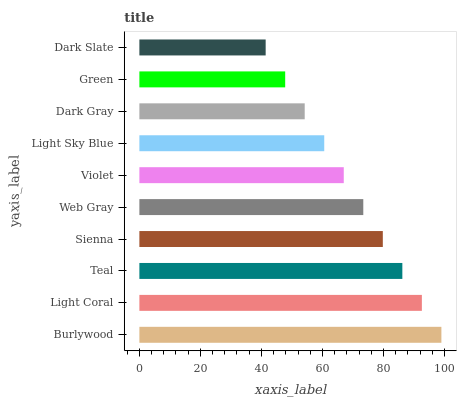Is Dark Slate the minimum?
Answer yes or no. Yes. Is Burlywood the maximum?
Answer yes or no. Yes. Is Light Coral the minimum?
Answer yes or no. No. Is Light Coral the maximum?
Answer yes or no. No. Is Burlywood greater than Light Coral?
Answer yes or no. Yes. Is Light Coral less than Burlywood?
Answer yes or no. Yes. Is Light Coral greater than Burlywood?
Answer yes or no. No. Is Burlywood less than Light Coral?
Answer yes or no. No. Is Web Gray the high median?
Answer yes or no. Yes. Is Violet the low median?
Answer yes or no. Yes. Is Green the high median?
Answer yes or no. No. Is Sienna the low median?
Answer yes or no. No. 